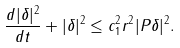<formula> <loc_0><loc_0><loc_500><loc_500>\frac { d | \delta | ^ { 2 } } { d t } + | \delta | ^ { 2 } \leq c _ { 1 } ^ { 2 } r ^ { 2 } | P \delta | ^ { 2 } .</formula> 